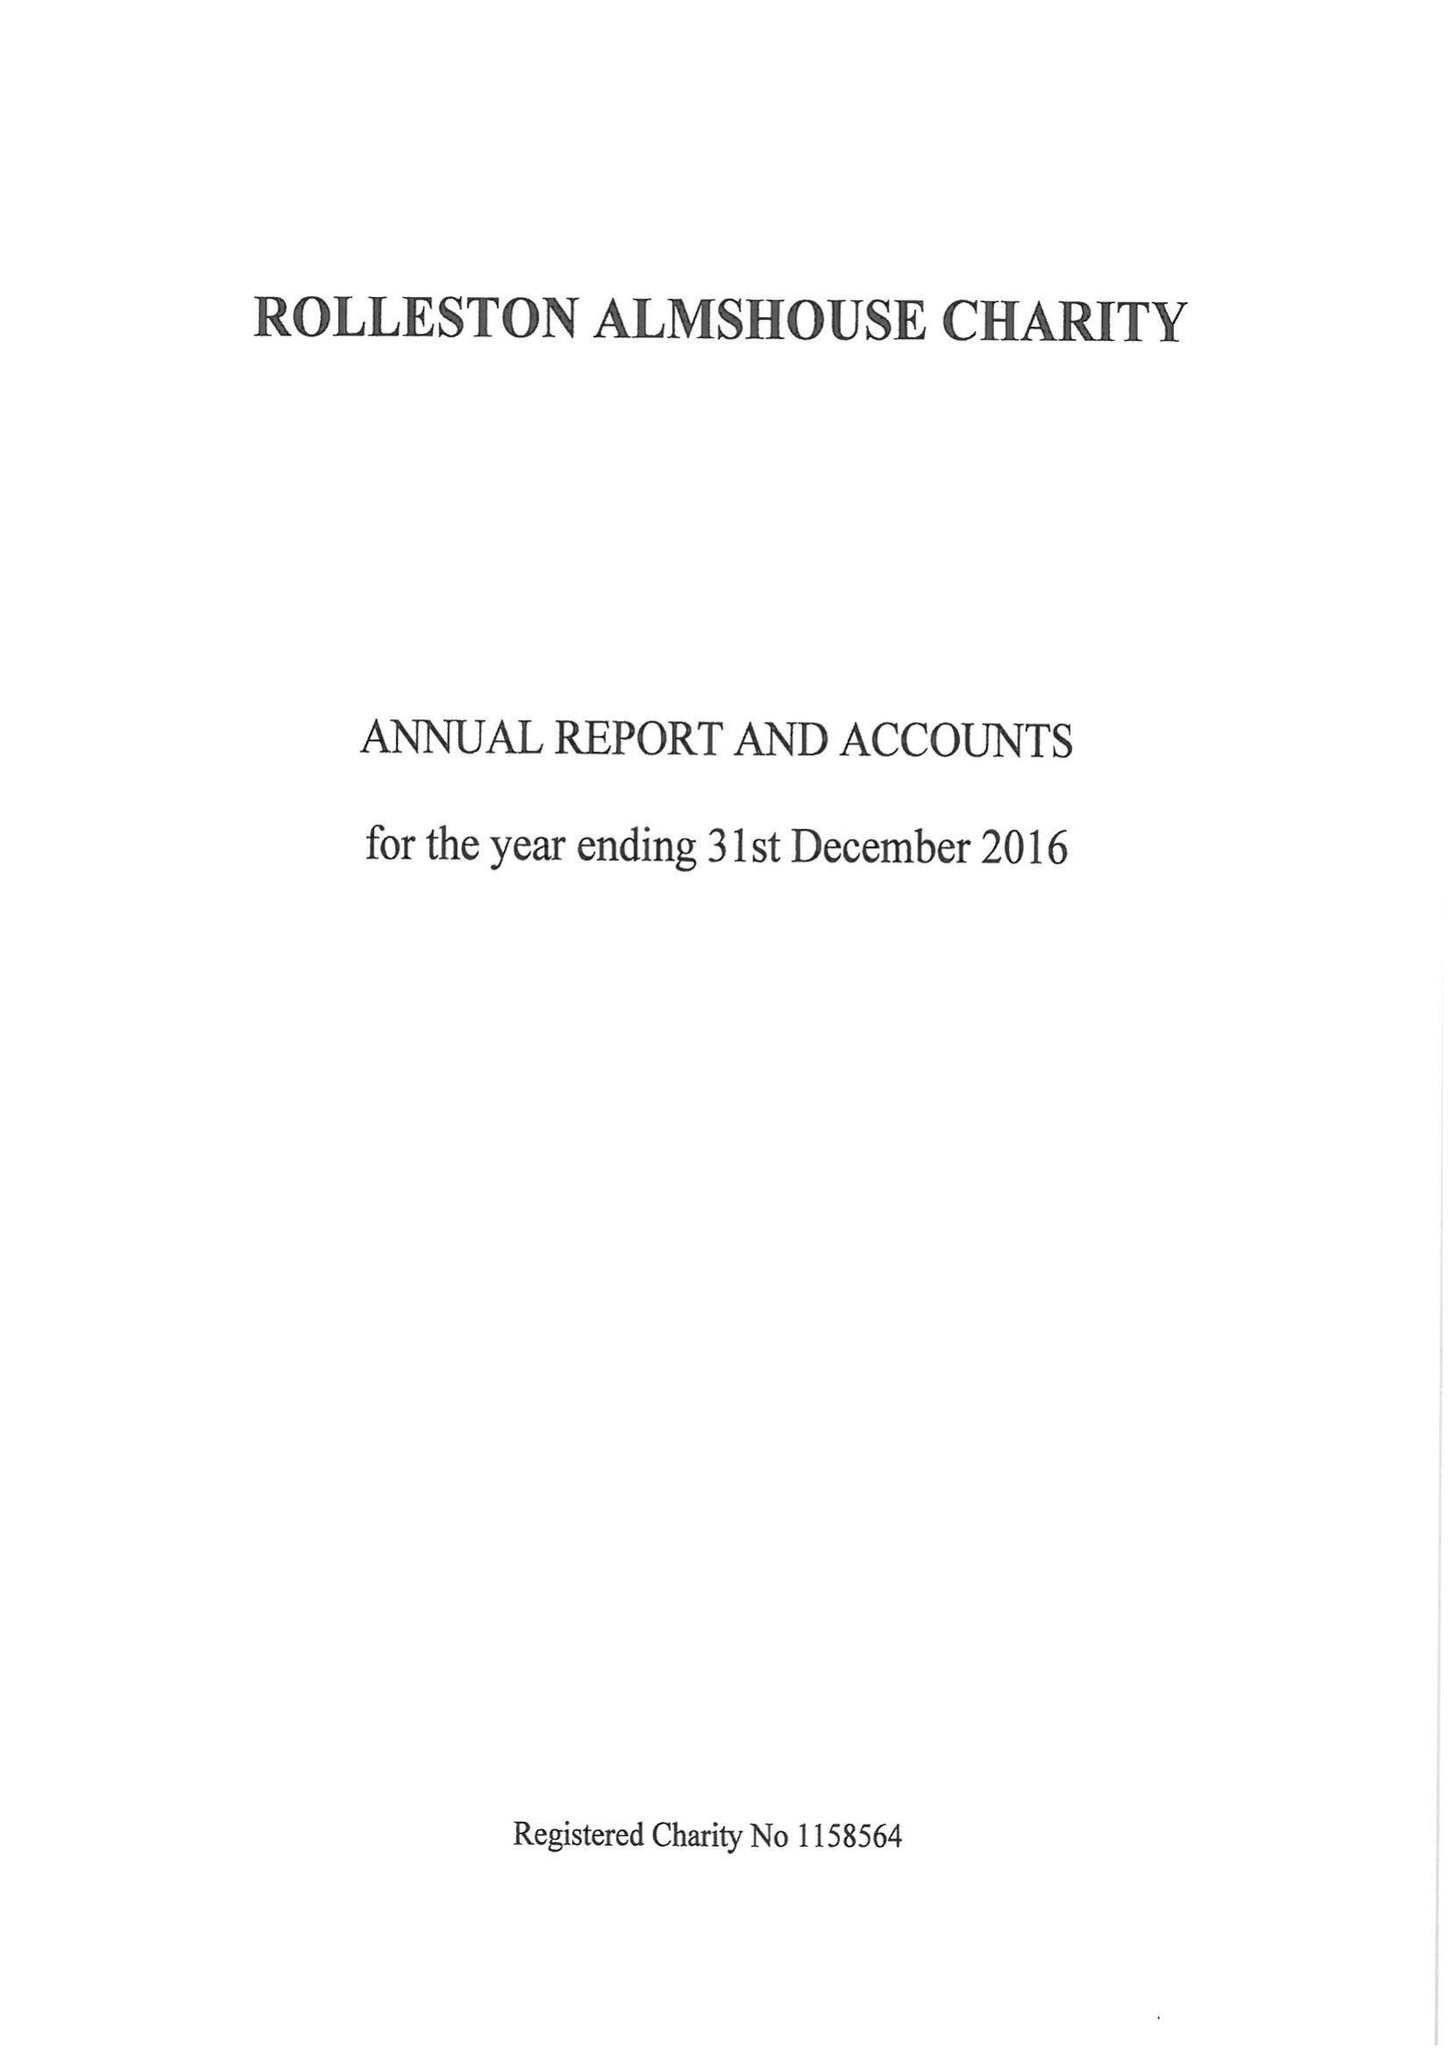What is the value for the report_date?
Answer the question using a single word or phrase. 2016-12-31 